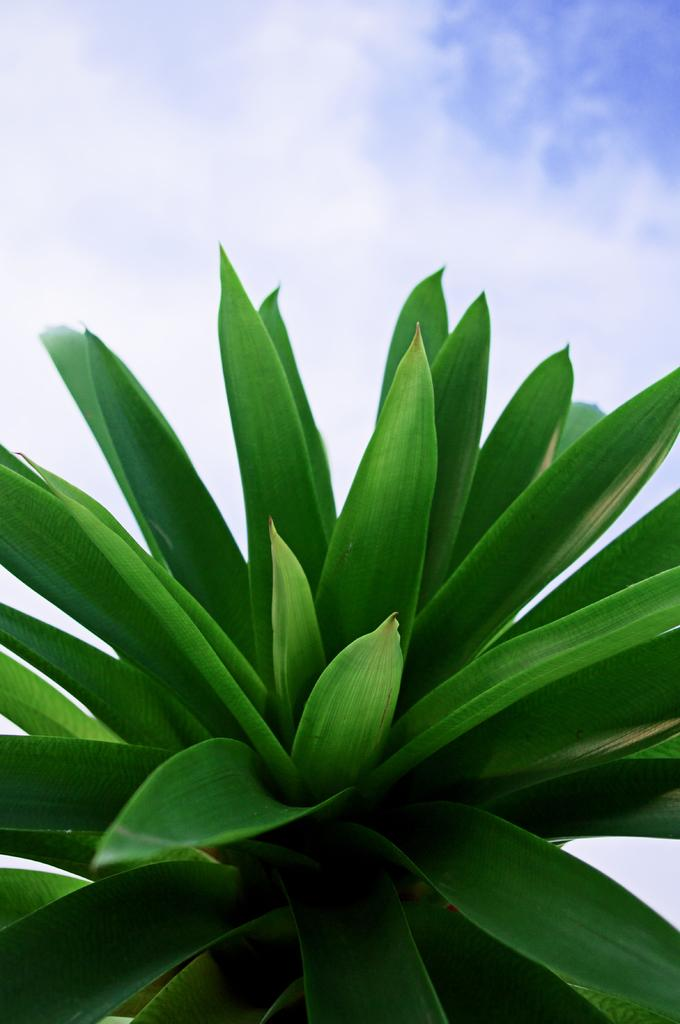Where was the image taken? The image was taken outdoors. What can be seen in the sky in the image? The sky with clouds is visible at the top of the image. What type of plant is in the middle of the image? There is a plant with green leaves in the middle of the image. How many hands are visible in the image? There are no hands visible in the image. What type of bushes are present in the image? There are no bushes present in the image. 